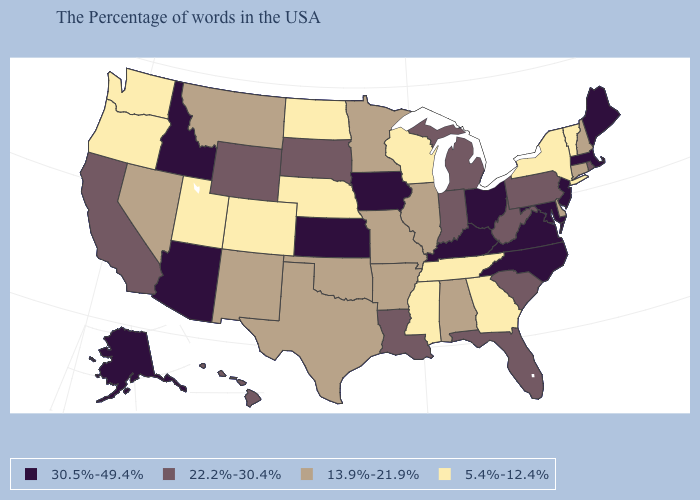Name the states that have a value in the range 22.2%-30.4%?
Answer briefly. Rhode Island, Pennsylvania, South Carolina, West Virginia, Florida, Michigan, Indiana, Louisiana, South Dakota, Wyoming, California, Hawaii. Name the states that have a value in the range 5.4%-12.4%?
Be succinct. Vermont, New York, Georgia, Tennessee, Wisconsin, Mississippi, Nebraska, North Dakota, Colorado, Utah, Washington, Oregon. Does Maine have a higher value than Connecticut?
Give a very brief answer. Yes. What is the highest value in the USA?
Be succinct. 30.5%-49.4%. Name the states that have a value in the range 13.9%-21.9%?
Keep it brief. New Hampshire, Connecticut, Delaware, Alabama, Illinois, Missouri, Arkansas, Minnesota, Oklahoma, Texas, New Mexico, Montana, Nevada. What is the value of Florida?
Quick response, please. 22.2%-30.4%. What is the lowest value in the USA?
Short answer required. 5.4%-12.4%. Does New Mexico have the highest value in the West?
Write a very short answer. No. What is the value of Colorado?
Quick response, please. 5.4%-12.4%. What is the value of New Mexico?
Quick response, please. 13.9%-21.9%. Which states hav the highest value in the West?
Short answer required. Arizona, Idaho, Alaska. Does North Dakota have the lowest value in the USA?
Answer briefly. Yes. Name the states that have a value in the range 22.2%-30.4%?
Short answer required. Rhode Island, Pennsylvania, South Carolina, West Virginia, Florida, Michigan, Indiana, Louisiana, South Dakota, Wyoming, California, Hawaii. Does California have the lowest value in the West?
Quick response, please. No. 